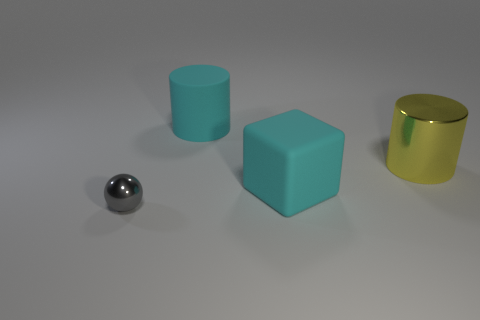There is a object that is the same color as the rubber block; what shape is it?
Make the answer very short. Cylinder. The rubber cylinder that is the same color as the large block is what size?
Your answer should be very brief. Large. How many cyan rubber things are the same size as the gray thing?
Ensure brevity in your answer.  0. There is a cyan object that is behind the large yellow cylinder; is its size the same as the metal thing that is on the left side of the big yellow metallic cylinder?
Your answer should be very brief. No. What shape is the large object that is both in front of the big matte cylinder and left of the yellow thing?
Make the answer very short. Cube. Is there a tiny metallic thing of the same color as the tiny metal ball?
Make the answer very short. No. Are there any tiny cyan rubber objects?
Your answer should be very brief. No. What is the color of the rubber thing in front of the yellow cylinder?
Make the answer very short. Cyan. Does the sphere have the same size as the cylinder left of the big cube?
Keep it short and to the point. No. There is a object that is in front of the yellow thing and left of the large rubber block; what size is it?
Offer a very short reply. Small. 